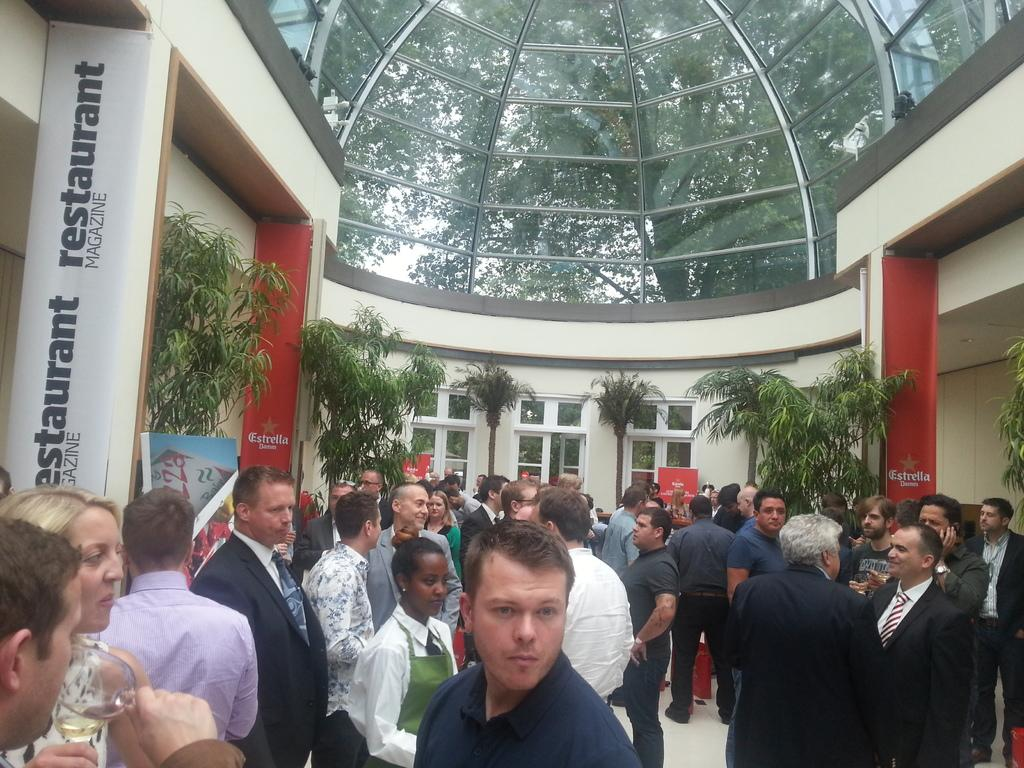How many people are in the image? There is a group of people in the image. Where are the people located in the image? The people are standing inside a building. What can be seen hanging in the image? There are banners in the image. What is the purpose of the board in the image? There is a board in the image, but its purpose is not specified in the facts. What type of vegetation is present in the image? There are plants and trees in the image. What part of the natural environment is visible in the image? The sky is visible in the image. What type of parent is depicted in the scene? There is no parent depicted in the image; it features a group of people standing inside a building. Who is the representative of the group in the image? The facts do not specify any representative of the group in the image. 